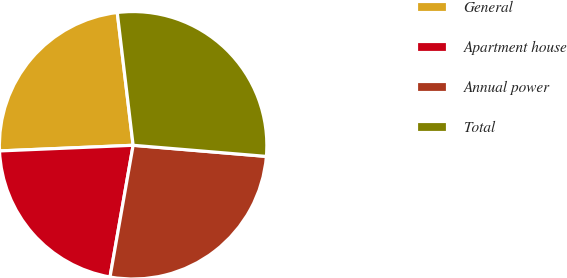Convert chart to OTSL. <chart><loc_0><loc_0><loc_500><loc_500><pie_chart><fcel>General<fcel>Apartment house<fcel>Annual power<fcel>Total<nl><fcel>23.78%<fcel>21.56%<fcel>26.44%<fcel>28.22%<nl></chart> 